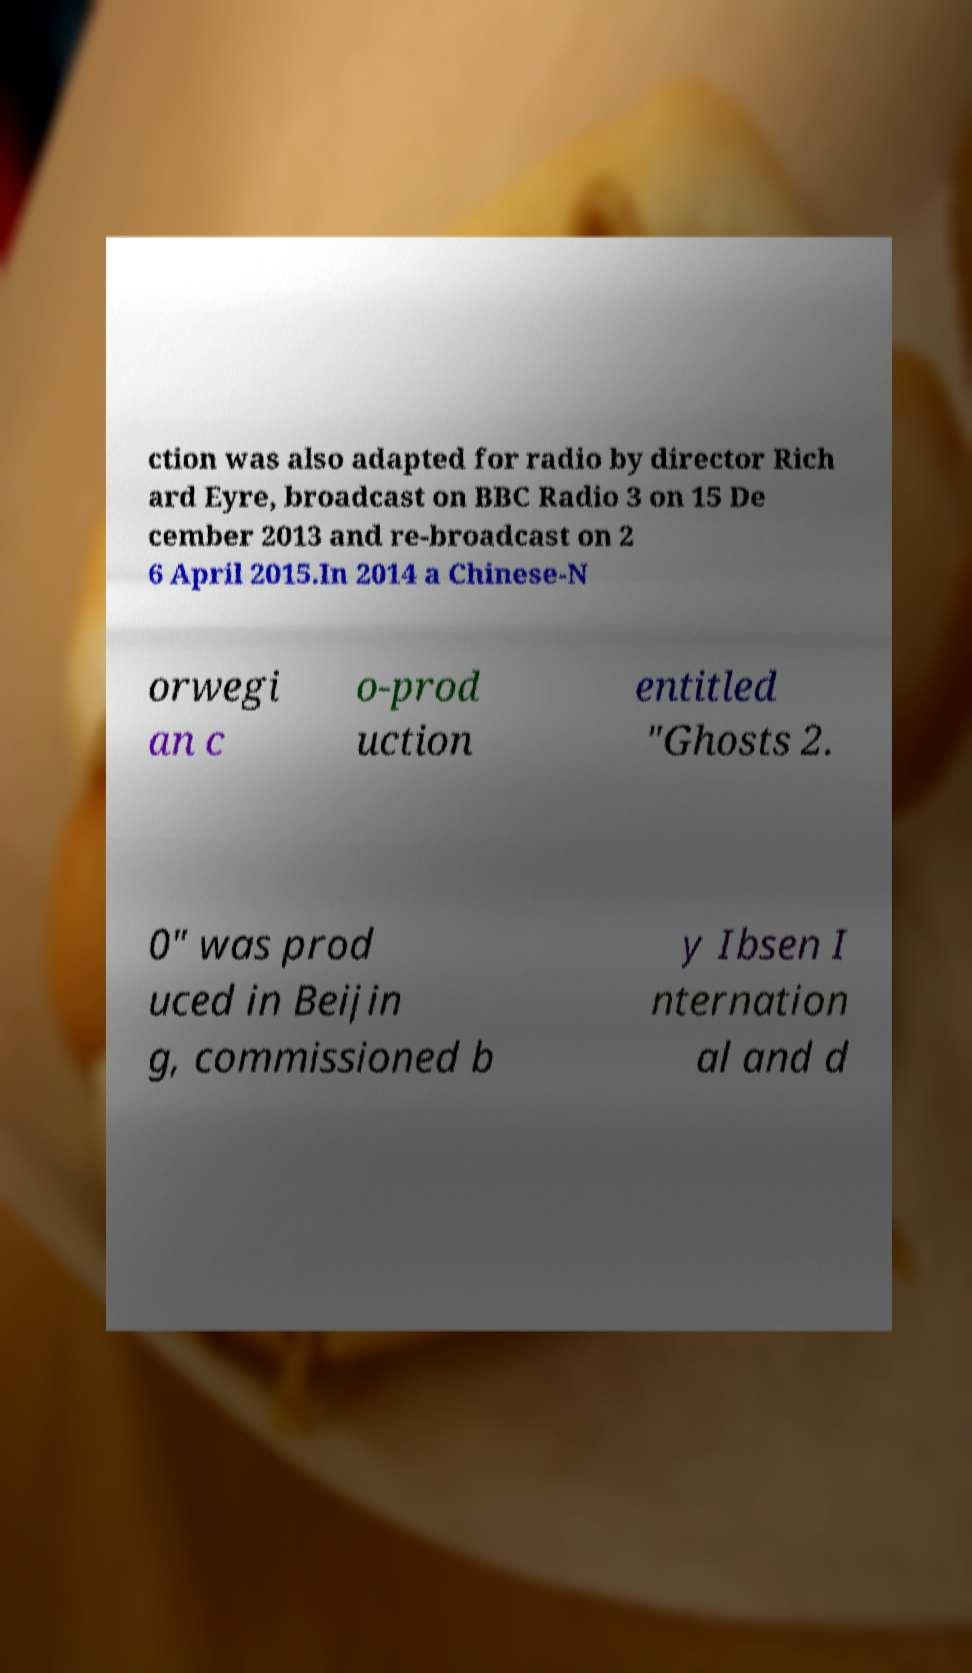For documentation purposes, I need the text within this image transcribed. Could you provide that? ction was also adapted for radio by director Rich ard Eyre, broadcast on BBC Radio 3 on 15 De cember 2013 and re-broadcast on 2 6 April 2015.In 2014 a Chinese-N orwegi an c o-prod uction entitled "Ghosts 2. 0" was prod uced in Beijin g, commissioned b y Ibsen I nternation al and d 